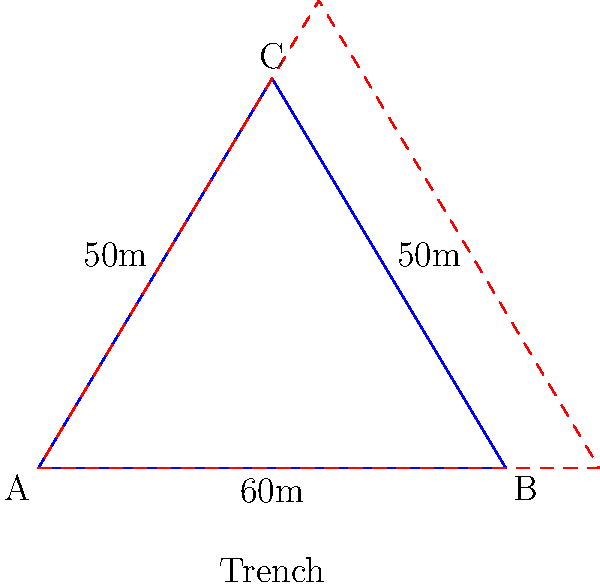A triangular military camp is surrounded by a defensive trench system. The camp's sides measure 60m, 50m, and 50m. The trench is constructed 2m outside the camp perimeter on all sides. Calculate the additional area that needs to be patrolled between the camp perimeter and the trench. How might this expanded patrol area impact the cultural dynamics and security practices within the camp? To solve this problem, we'll follow these steps:

1) First, calculate the semi-perimeter ($s$) of the triangular camp:
   $s = \frac{60 + 50 + 50}{2} = 80$ m

2) Use Heron's formula to calculate the area of the camp:
   $A_1 = \sqrt{s(s-a)(s-b)(s-c)}$
   $A_1 = \sqrt{80(80-60)(80-50)(80-50)} = \sqrt{80 * 20 * 30 * 30} = 600$ sq m

3) Calculate the semi-perimeter of the trench ($s_2$):
   Each side of the trench is 4m longer than the corresponding side of the camp.
   $s_2 = \frac{(60+4) + (50+4) + (50+4)}{2} = \frac{168}{2} = 84$ m

4) Calculate the area enclosed by the trench using Heron's formula:
   $A_2 = \sqrt{84(84-64)(84-54)(84-54)} = \sqrt{84 * 20 * 30 * 30} = 660$ sq m

5) The additional area to be patrolled is the difference between these areas:
   Additional Area = $660 - 600 = 60$ sq m

From an anthropological perspective, this expanded patrol area could impact the camp's culture in several ways:

1) Increased security personnel needed, potentially altering the camp's social structure.
2) More time and resources devoted to security, possibly affecting other cultural activities.
3) The additional buffer zone might create a psychological effect of increased safety or isolation.
4) The trench system could become a physical manifestation of the camp's boundaries, influencing perceptions of insider/outsider dynamics.
Answer: 60 sq m 